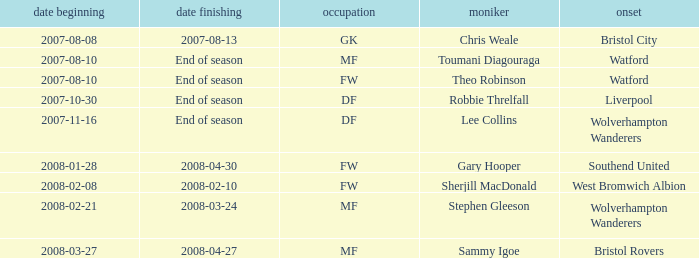What was the name for the row with Date From of 2008-02-21? Stephen Gleeson. 